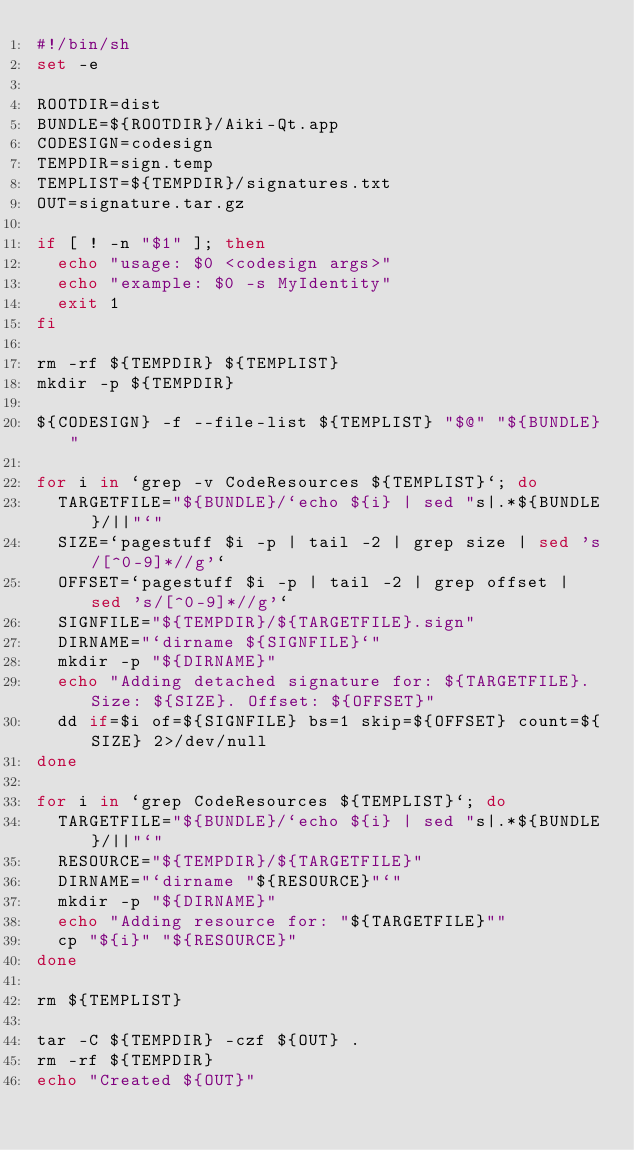Convert code to text. <code><loc_0><loc_0><loc_500><loc_500><_Bash_>#!/bin/sh
set -e

ROOTDIR=dist
BUNDLE=${ROOTDIR}/Aiki-Qt.app
CODESIGN=codesign
TEMPDIR=sign.temp
TEMPLIST=${TEMPDIR}/signatures.txt
OUT=signature.tar.gz

if [ ! -n "$1" ]; then
  echo "usage: $0 <codesign args>"
  echo "example: $0 -s MyIdentity"
  exit 1
fi

rm -rf ${TEMPDIR} ${TEMPLIST}
mkdir -p ${TEMPDIR}

${CODESIGN} -f --file-list ${TEMPLIST} "$@" "${BUNDLE}"

for i in `grep -v CodeResources ${TEMPLIST}`; do
  TARGETFILE="${BUNDLE}/`echo ${i} | sed "s|.*${BUNDLE}/||"`"
  SIZE=`pagestuff $i -p | tail -2 | grep size | sed 's/[^0-9]*//g'`
  OFFSET=`pagestuff $i -p | tail -2 | grep offset | sed 's/[^0-9]*//g'`
  SIGNFILE="${TEMPDIR}/${TARGETFILE}.sign"
  DIRNAME="`dirname ${SIGNFILE}`"
  mkdir -p "${DIRNAME}"
  echo "Adding detached signature for: ${TARGETFILE}. Size: ${SIZE}. Offset: ${OFFSET}"
  dd if=$i of=${SIGNFILE} bs=1 skip=${OFFSET} count=${SIZE} 2>/dev/null
done

for i in `grep CodeResources ${TEMPLIST}`; do
  TARGETFILE="${BUNDLE}/`echo ${i} | sed "s|.*${BUNDLE}/||"`"
  RESOURCE="${TEMPDIR}/${TARGETFILE}"
  DIRNAME="`dirname "${RESOURCE}"`"
  mkdir -p "${DIRNAME}"
  echo "Adding resource for: "${TARGETFILE}""
  cp "${i}" "${RESOURCE}"
done

rm ${TEMPLIST}

tar -C ${TEMPDIR} -czf ${OUT} .
rm -rf ${TEMPDIR}
echo "Created ${OUT}"
</code> 